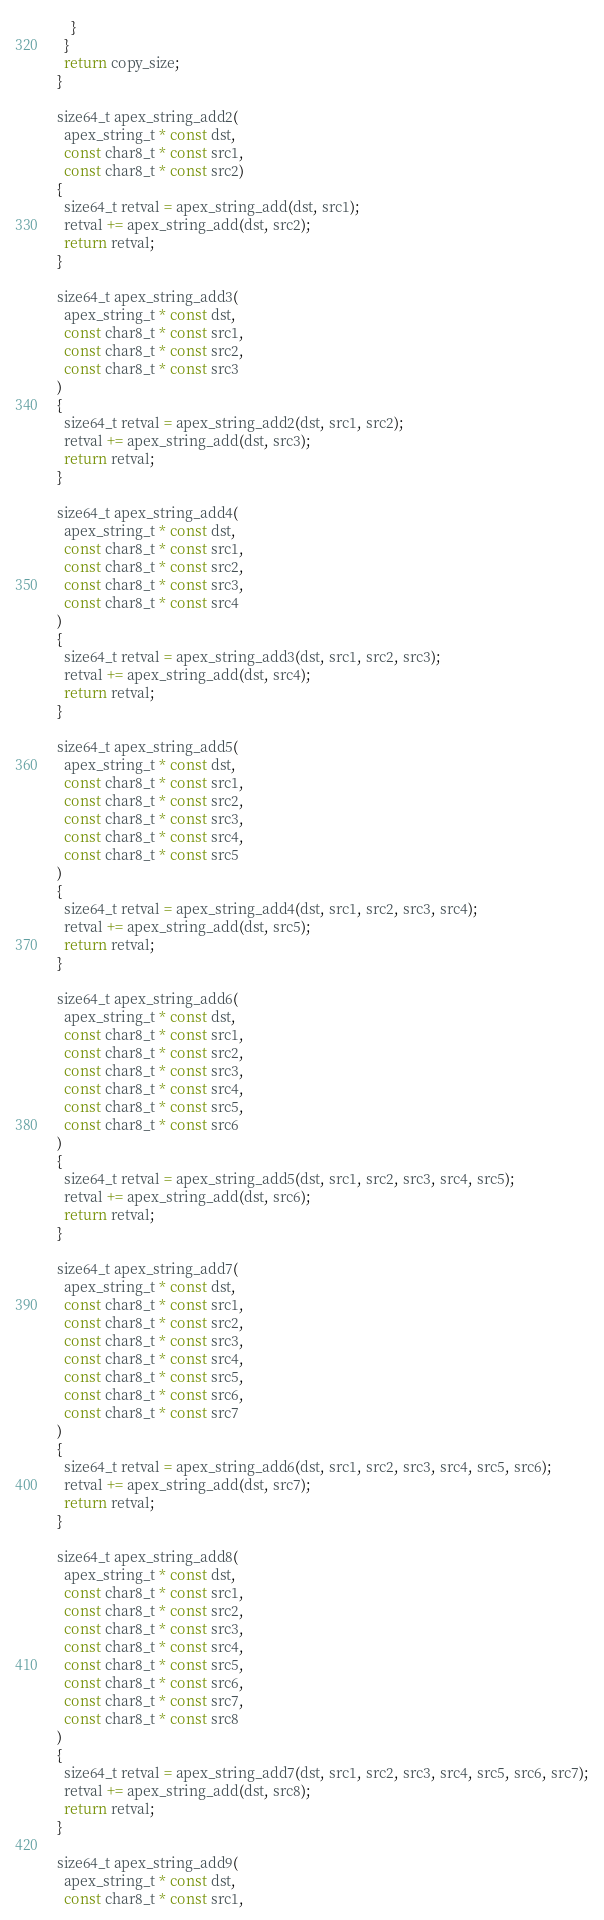<code> <loc_0><loc_0><loc_500><loc_500><_C_>    }
  }
  return copy_size;
}

size64_t apex_string_add2(
  apex_string_t * const dst,
  const char8_t * const src1,
  const char8_t * const src2)
{
  size64_t retval = apex_string_add(dst, src1);
  retval += apex_string_add(dst, src2);
  return retval;
}

size64_t apex_string_add3(
  apex_string_t * const dst,
  const char8_t * const src1,
  const char8_t * const src2,
  const char8_t * const src3
)
{
  size64_t retval = apex_string_add2(dst, src1, src2);
  retval += apex_string_add(dst, src3);
  return retval;
}

size64_t apex_string_add4(
  apex_string_t * const dst,
  const char8_t * const src1,
  const char8_t * const src2,
  const char8_t * const src3,
  const char8_t * const src4
)
{
  size64_t retval = apex_string_add3(dst, src1, src2, src3);
  retval += apex_string_add(dst, src4);
  return retval;
}

size64_t apex_string_add5(
  apex_string_t * const dst,
  const char8_t * const src1,
  const char8_t * const src2,
  const char8_t * const src3,
  const char8_t * const src4,
  const char8_t * const src5
)
{
  size64_t retval = apex_string_add4(dst, src1, src2, src3, src4);
  retval += apex_string_add(dst, src5);
  return retval;
}

size64_t apex_string_add6(
  apex_string_t * const dst,
  const char8_t * const src1,
  const char8_t * const src2,
  const char8_t * const src3,
  const char8_t * const src4,
  const char8_t * const src5,
  const char8_t * const src6
)
{
  size64_t retval = apex_string_add5(dst, src1, src2, src3, src4, src5);
  retval += apex_string_add(dst, src6);
  return retval;
}

size64_t apex_string_add7(
  apex_string_t * const dst,
  const char8_t * const src1,
  const char8_t * const src2,
  const char8_t * const src3,
  const char8_t * const src4,
  const char8_t * const src5,
  const char8_t * const src6,
  const char8_t * const src7
)
{
  size64_t retval = apex_string_add6(dst, src1, src2, src3, src4, src5, src6);
  retval += apex_string_add(dst, src7);
  return retval;
}

size64_t apex_string_add8(
  apex_string_t * const dst,
  const char8_t * const src1,
  const char8_t * const src2,
  const char8_t * const src3,
  const char8_t * const src4,
  const char8_t * const src5,
  const char8_t * const src6,
  const char8_t * const src7,
  const char8_t * const src8
)
{
  size64_t retval = apex_string_add7(dst, src1, src2, src3, src4, src5, src6, src7);
  retval += apex_string_add(dst, src8);
  return retval;
}

size64_t apex_string_add9(
  apex_string_t * const dst,
  const char8_t * const src1,</code> 